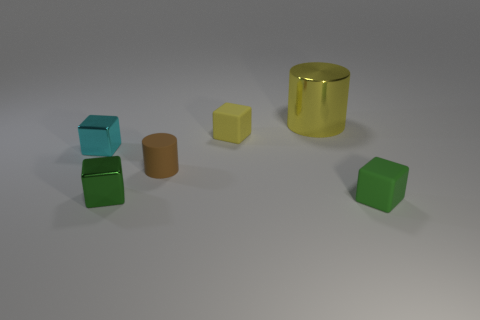Are there any other things that have the same size as the yellow metal cylinder?
Your response must be concise. No. There is a rubber block that is behind the green matte object; is its color the same as the matte cube that is in front of the brown rubber object?
Offer a terse response. No. Are there more things to the left of the tiny yellow block than tiny objects?
Ensure brevity in your answer.  No. What material is the yellow block?
Provide a succinct answer. Rubber. What is the shape of the yellow object that is the same material as the cyan object?
Keep it short and to the point. Cylinder. How big is the yellow cube behind the tiny matte object that is on the left side of the yellow matte cube?
Keep it short and to the point. Small. There is a matte block behind the rubber cylinder; what is its color?
Give a very brief answer. Yellow. Are there any other gray matte objects that have the same shape as the large thing?
Ensure brevity in your answer.  No. Is the number of big cylinders in front of the shiny cylinder less than the number of yellow rubber objects right of the tiny yellow block?
Make the answer very short. No. The tiny cylinder is what color?
Make the answer very short. Brown. 